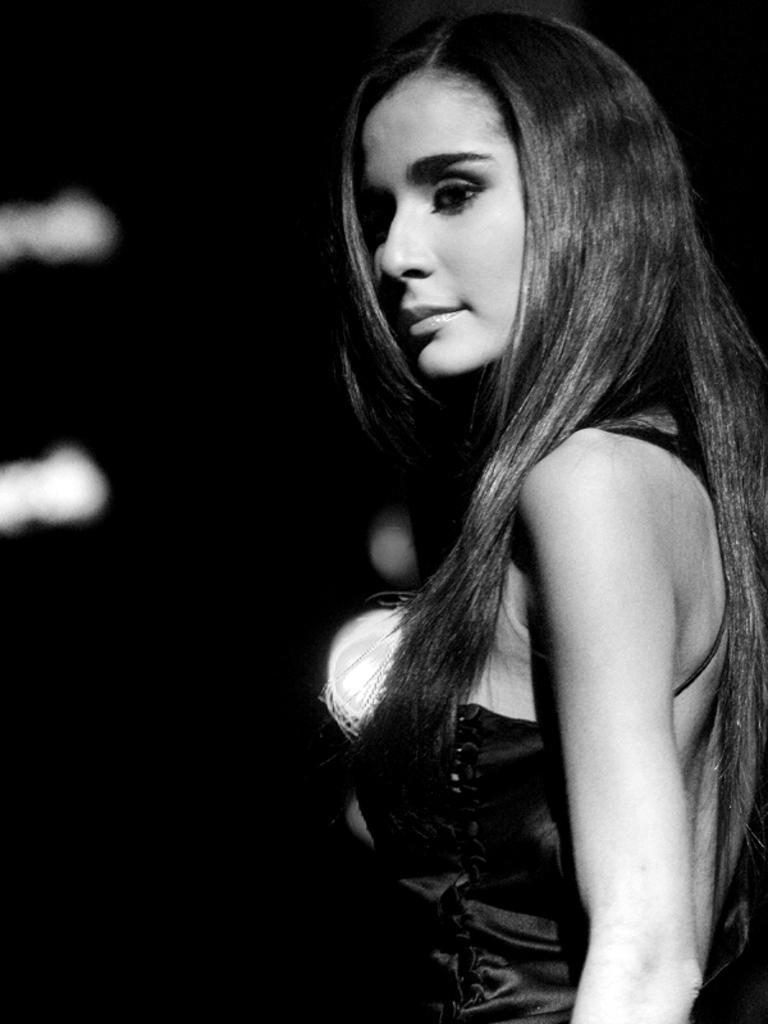How would you summarize this image in a sentence or two? In this image there is a woman standing, there are lights, the background of the image is dark. 